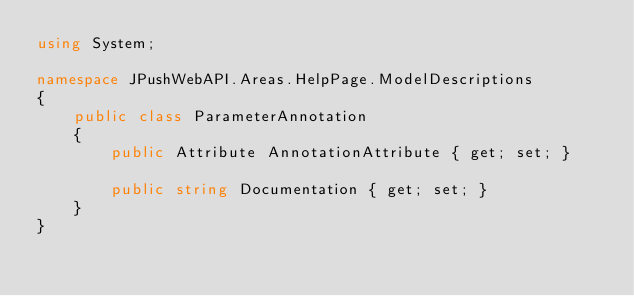Convert code to text. <code><loc_0><loc_0><loc_500><loc_500><_C#_>using System;

namespace JPushWebAPI.Areas.HelpPage.ModelDescriptions
{
    public class ParameterAnnotation
    {
        public Attribute AnnotationAttribute { get; set; }

        public string Documentation { get; set; }
    }
}</code> 